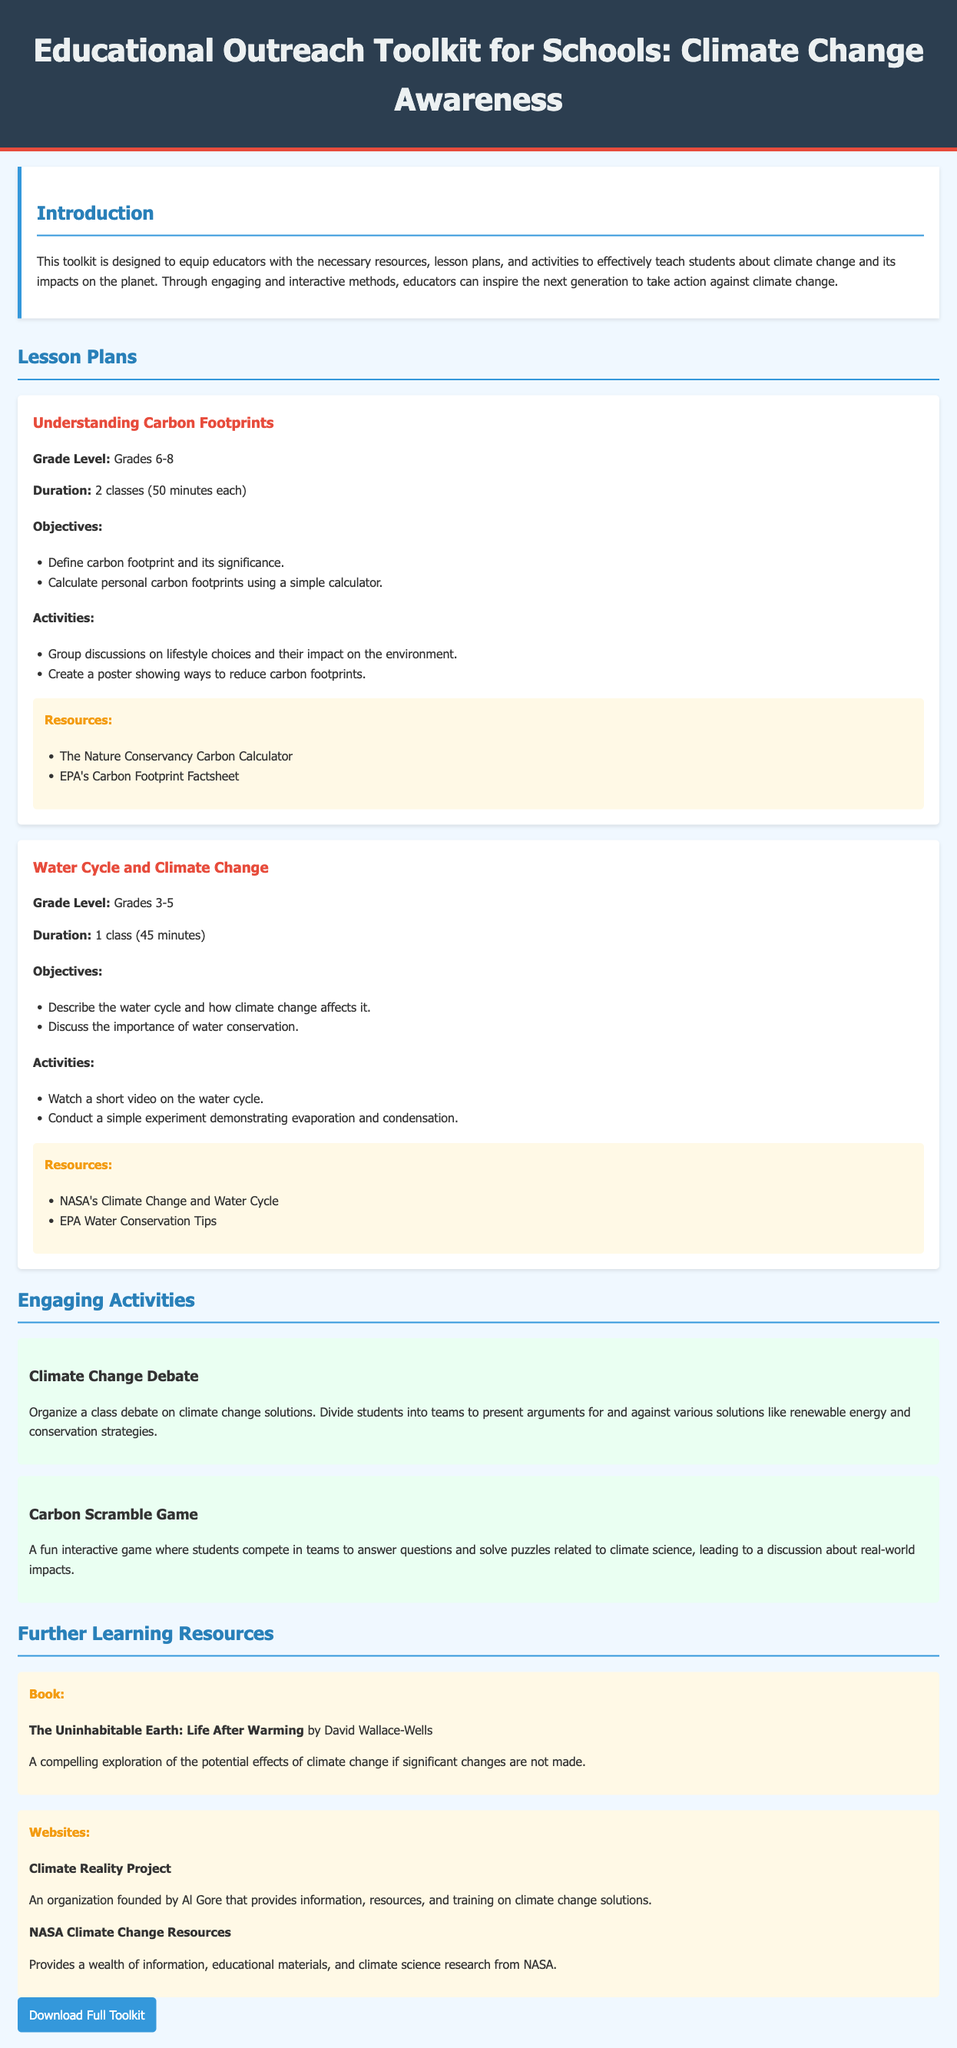What is the title of the toolkit? The title of the toolkit is mentioned in the header section of the document.
Answer: Educational Outreach Toolkit for Schools: Climate Change Awareness What is the grade level for the lesson plan on carbon footprints? The document specifies the grade level in the understanding carbon footprints lesson plan section.
Answer: Grades 6-8 What is the duration of the water cycle lesson plan? The duration is provided under the water cycle lesson plan details.
Answer: 1 class (45 minutes) Name one resource listed for the carbon footprint lesson plan. The resources for the carbon footprint lesson plan are mentioned specifically in that section.
Answer: The Nature Conservancy Carbon Calculator How many activities are provided under engaging activities? The number of activities can be counted in the engaging activities section of the document.
Answer: 2 What is the objective of the water cycle lesson plan? The objectives are outlined in the water cycle lesson plan section.
Answer: Describe the water cycle and how climate change affects it What type of game is mentioned as an engaging activity? The document includes a specific type of game within the engaging activities section.
Answer: Carbon Scramble Game Who founded the Climate Reality Project? The document mentions Al Gore in relation to the Climate Reality Project.
Answer: Al Gore 